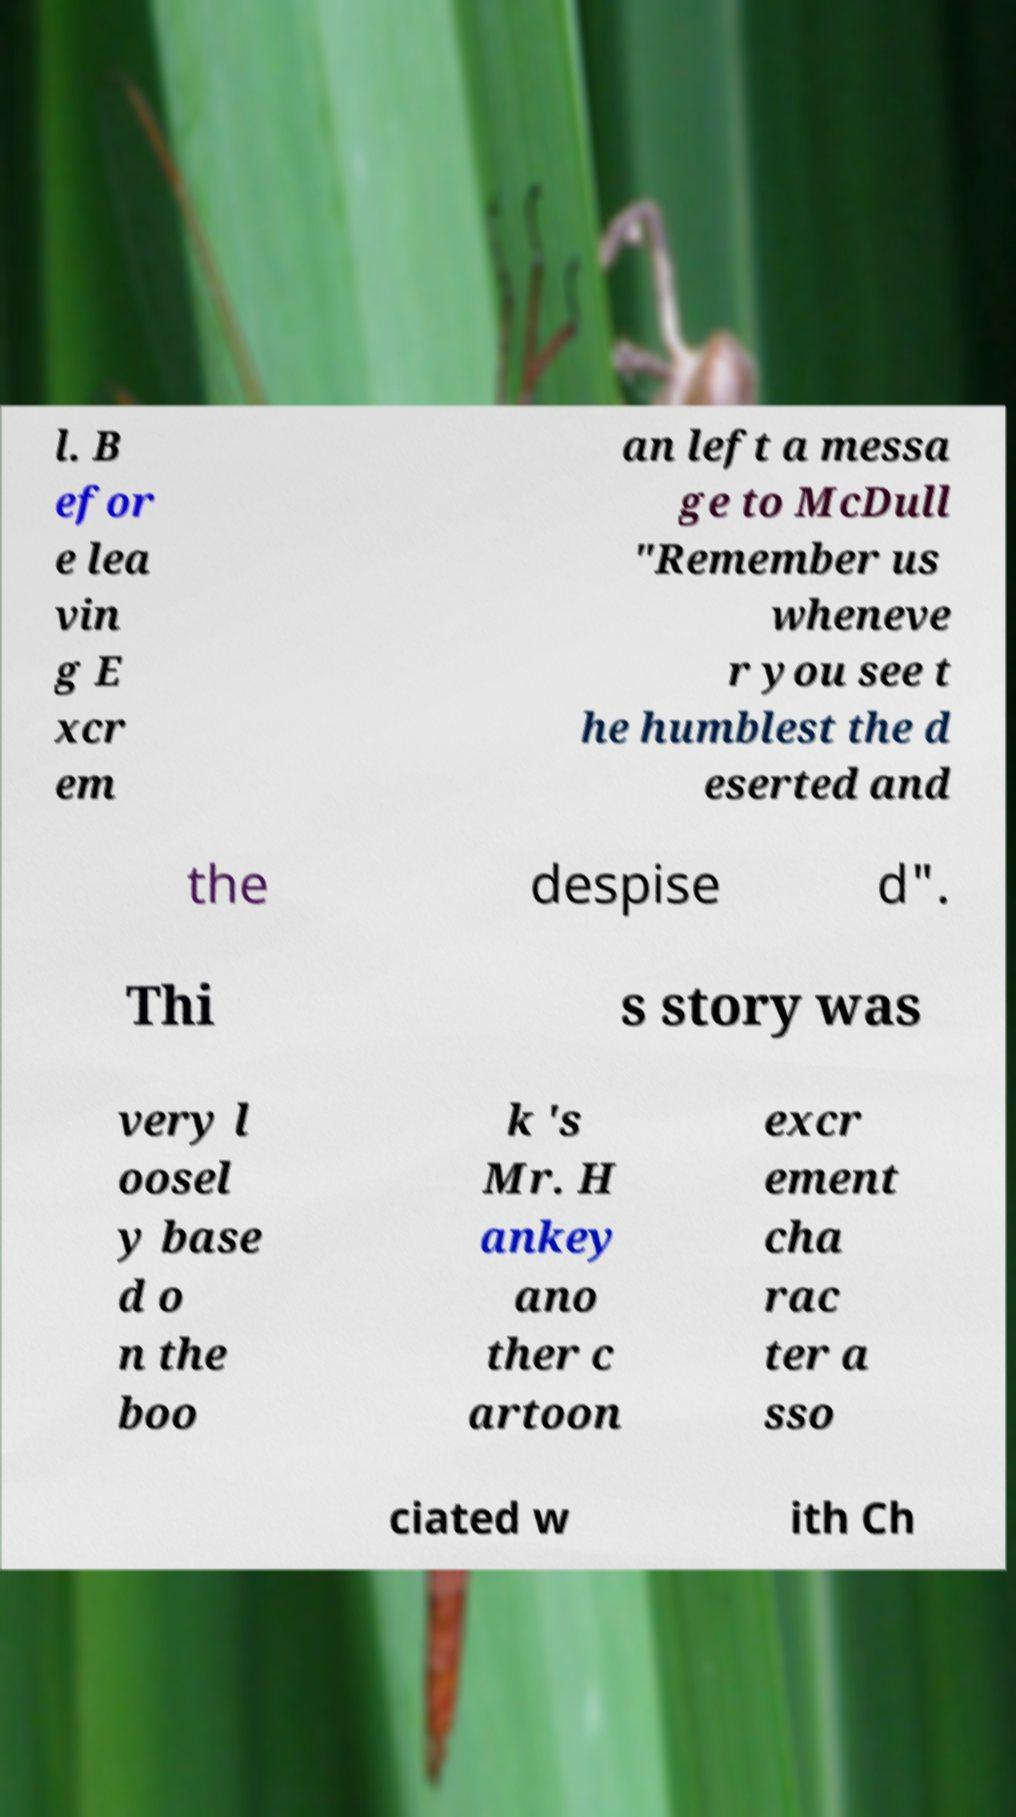There's text embedded in this image that I need extracted. Can you transcribe it verbatim? l. B efor e lea vin g E xcr em an left a messa ge to McDull "Remember us wheneve r you see t he humblest the d eserted and the despise d". Thi s story was very l oosel y base d o n the boo k 's Mr. H ankey ano ther c artoon excr ement cha rac ter a sso ciated w ith Ch 